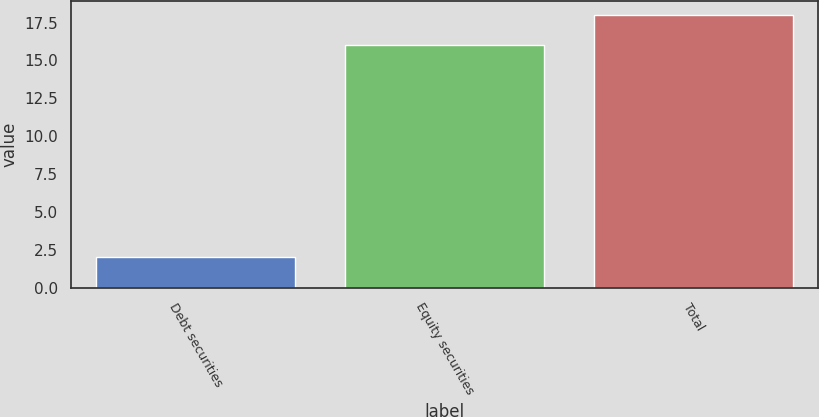<chart> <loc_0><loc_0><loc_500><loc_500><bar_chart><fcel>Debt securities<fcel>Equity securities<fcel>Total<nl><fcel>2<fcel>16<fcel>18<nl></chart> 